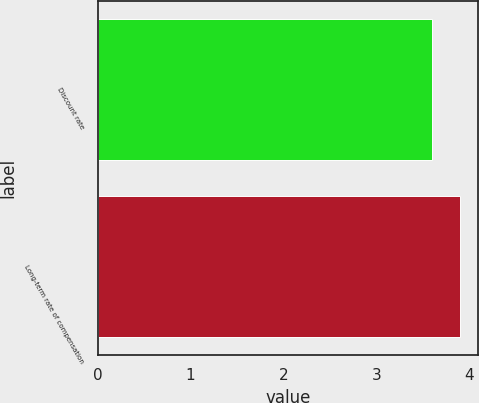Convert chart to OTSL. <chart><loc_0><loc_0><loc_500><loc_500><bar_chart><fcel>Discount rate<fcel>Long-term rate of compensation<nl><fcel>3.6<fcel>3.9<nl></chart> 